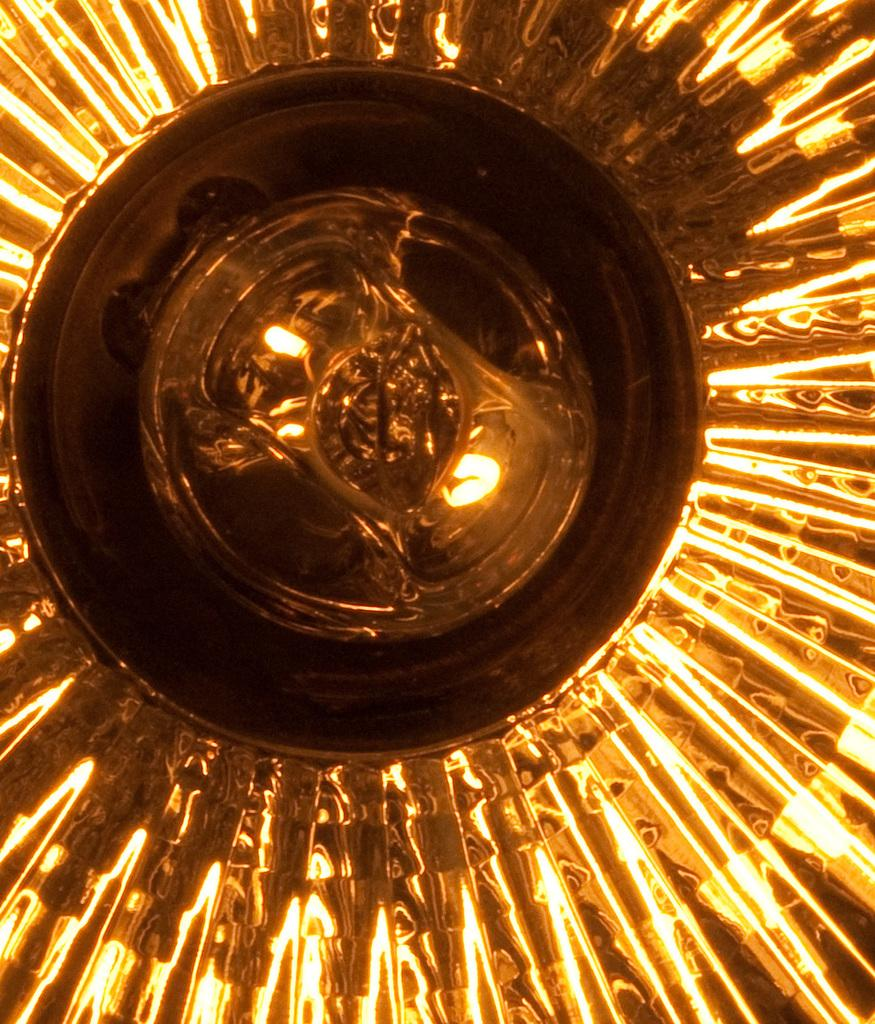What can be seen in the image that provides illumination? There are lights in the image. What type of space is visible in the image? There is no space visible in the image; the focus is on the lights. Are there any stockings present in the image? There is no mention of stockings in the image, as the focus is on the lights. 